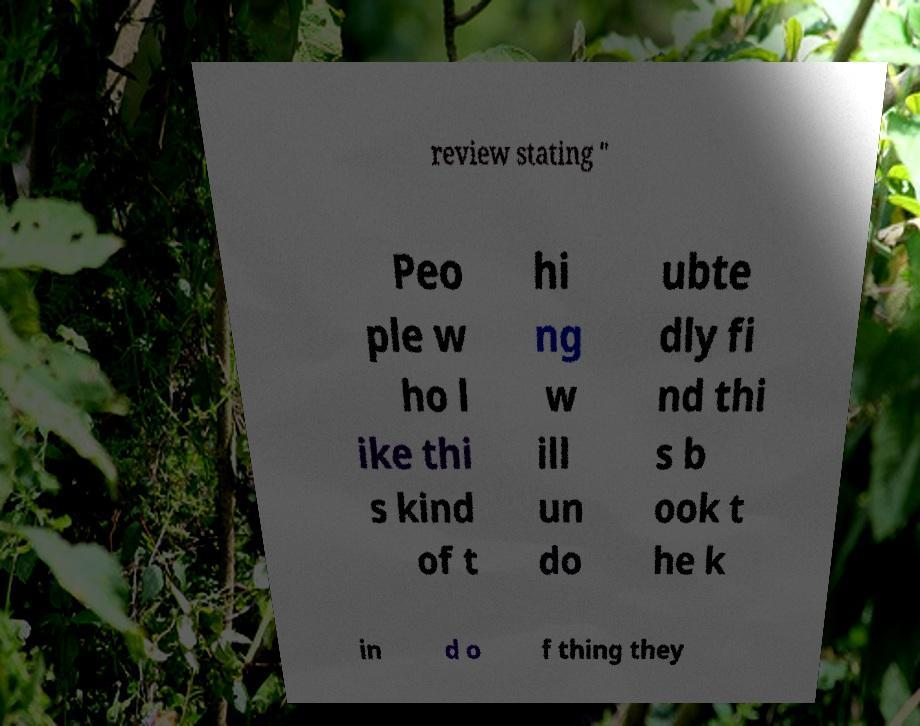Please read and relay the text visible in this image. What does it say? review stating " Peo ple w ho l ike thi s kind of t hi ng w ill un do ubte dly fi nd thi s b ook t he k in d o f thing they 